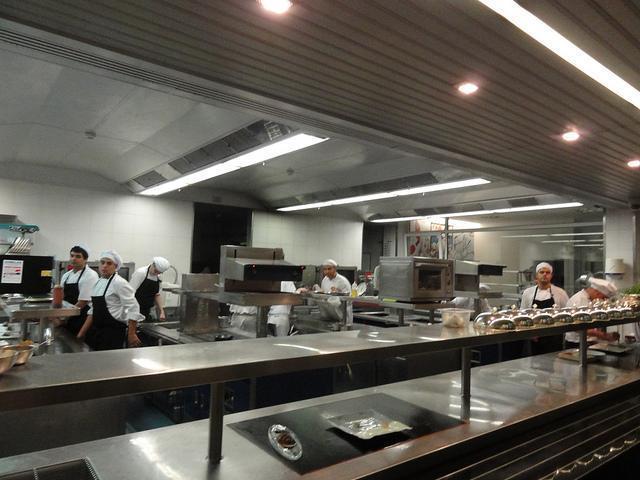How many people can be seen?
Give a very brief answer. 2. How many red umbrellas are there?
Give a very brief answer. 0. 